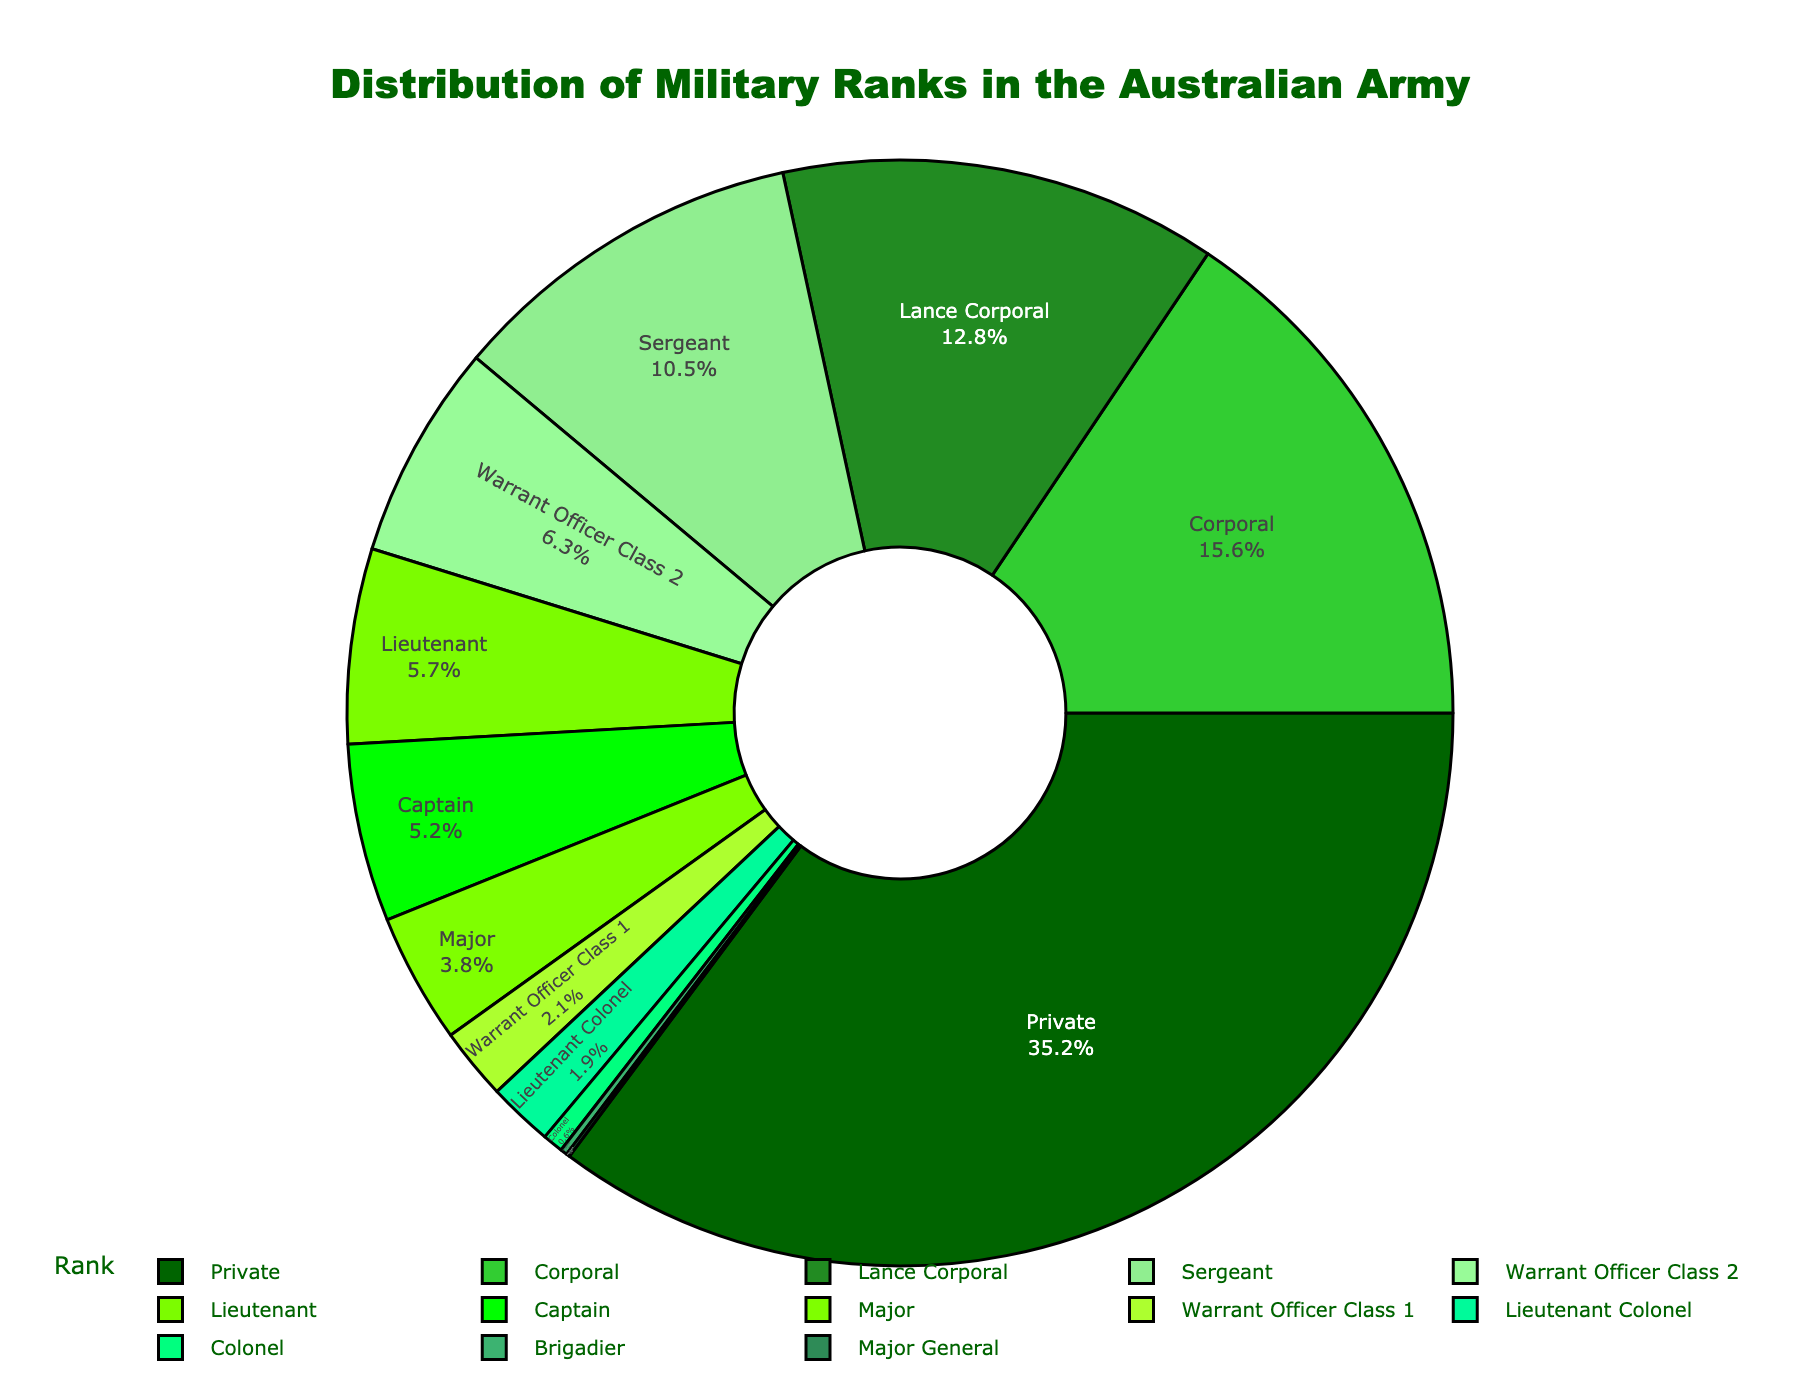What rank holds the highest percentage in the Australian Army distribution? To find the highest percentage, look at each segment of the pie chart. The "Private" rank has the largest segment.
Answer: Private What is the total percentage of Warrant Officers in the chart? Add the percentages for "Warrant Officer Class 2" and "Warrant Officer Class 1". Warrant Officer Class 2 is 6.3% and Warrant Officer Class 1 is 2.1%. So, 6.3% + 2.1% = 8.4%.
Answer: 8.4% Is the percentage of Captains greater than that of Lieutenants? Compare the percentages directly from the chart: Captain (5.2%) and Lieutenant (5.7%). 5.2% is less than 5.7%.
Answer: No Which rank among Lance Corporal, Corporal, and Sergeant has the lowest percentage? From the chart, check the percentages: Lance Corporal (12.8%), Corporal (15.6%), and Sergeant (10.5%). Sergeant has the lowest percentage among the three.
Answer: Sergeant What is the combined percentage of ranks Lieutenant Colonel, Colonel, Brigadier, and Major General? Add the percentages for "Lieutenant Colonel" (1.9%), "Colonel" (0.6%), "Brigadier" (0.2%), and "Major General" (0.1%). So, 1.9% + 0.6% + 0.2% + 0.1% = 2.8%.
Answer: 2.8% What rank is represented by a green segment roughly in the middle of the greens in terms of intensity? The ranks are colored in shades of green. Warrant Officer Class 2, with a percentage of 6.3%, appears in the middle of the green shades in terms of intensity.
Answer: Warrant Officer Class 2 Which rank has a percentage closest to 5% but not exceeding it? Compare the percentages around 5%: Captain (5.2%), Major (3.8%), and Lieutenant (5.7%). While Captain (5.2%) exceeds 5%, Major (3.8%) is closest to but does not exceed 5%.
Answer: Major What is the difference in percentage between Corporals and Majors? Subtract the percentage of Majors from Corporals. Corporal (15.6%) and Major (3.8%): 15.6% - 3.8% = 11.8%.
Answer: 11.8% How many ranks have percentages below 1%? Check the chart to count ranks with percentages below 1%: Colonel (0.6%), Brigadier (0.2%), Major General (0.1%). There are 3 ranks.
Answer: 3 